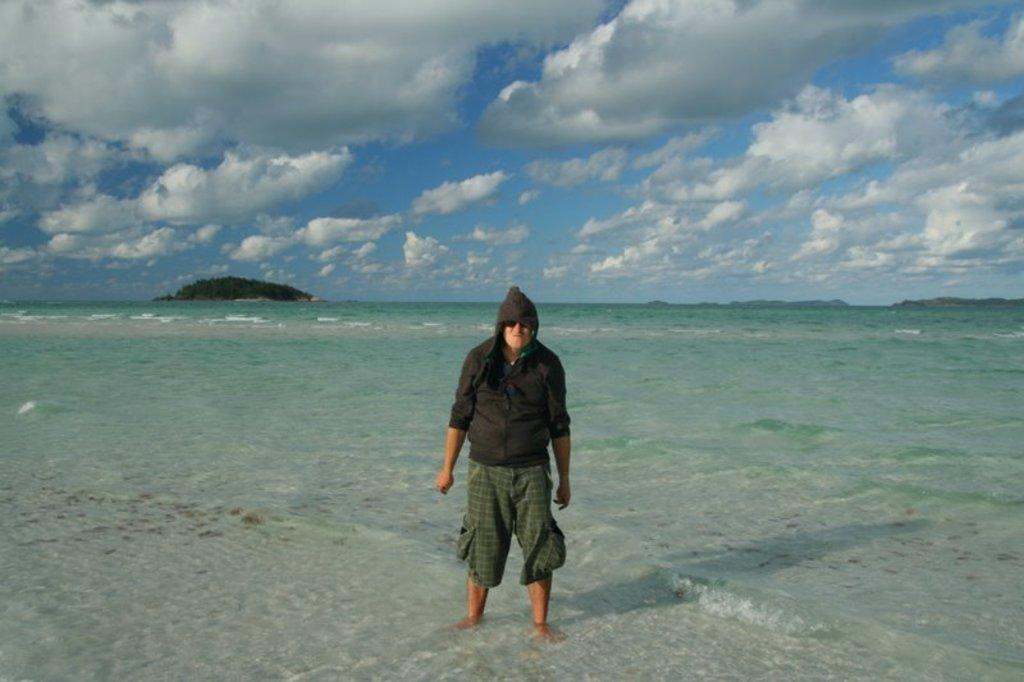What is the main subject of the image? There is a person standing in the image. What is the person wearing? The person is wearing clothes. What natural feature can be seen in the background of the image? There is a sea visible in the image. What type of landform is present in the image? There is a hill in the image. How would you describe the weather based on the image? The sky is cloudy in the image. How many eyes can be seen on the property in the image? There is no property or eyes present in the image; it features a person standing near a sea and a hill with a cloudy sky. 